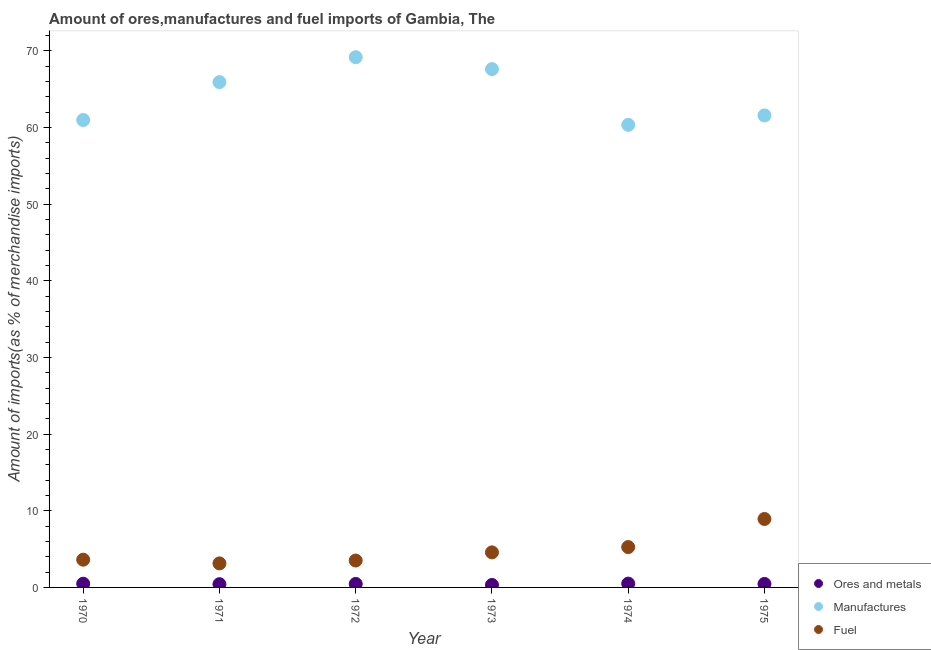How many different coloured dotlines are there?
Ensure brevity in your answer.  3. What is the percentage of fuel imports in 1970?
Your answer should be compact. 3.62. Across all years, what is the maximum percentage of fuel imports?
Ensure brevity in your answer.  8.93. Across all years, what is the minimum percentage of manufactures imports?
Offer a very short reply. 60.34. In which year was the percentage of ores and metals imports maximum?
Make the answer very short. 1974. In which year was the percentage of ores and metals imports minimum?
Offer a very short reply. 1973. What is the total percentage of ores and metals imports in the graph?
Ensure brevity in your answer.  2.64. What is the difference between the percentage of ores and metals imports in 1972 and that in 1973?
Ensure brevity in your answer.  0.14. What is the difference between the percentage of fuel imports in 1975 and the percentage of manufactures imports in 1972?
Provide a succinct answer. -60.23. What is the average percentage of ores and metals imports per year?
Offer a terse response. 0.44. In the year 1974, what is the difference between the percentage of ores and metals imports and percentage of manufactures imports?
Ensure brevity in your answer.  -59.84. What is the ratio of the percentage of ores and metals imports in 1971 to that in 1974?
Offer a terse response. 0.85. Is the percentage of manufactures imports in 1970 less than that in 1975?
Provide a succinct answer. Yes. Is the difference between the percentage of fuel imports in 1972 and 1974 greater than the difference between the percentage of manufactures imports in 1972 and 1974?
Ensure brevity in your answer.  No. What is the difference between the highest and the second highest percentage of manufactures imports?
Your answer should be compact. 1.55. What is the difference between the highest and the lowest percentage of manufactures imports?
Keep it short and to the point. 8.82. Is the sum of the percentage of manufactures imports in 1972 and 1973 greater than the maximum percentage of fuel imports across all years?
Offer a terse response. Yes. Is it the case that in every year, the sum of the percentage of ores and metals imports and percentage of manufactures imports is greater than the percentage of fuel imports?
Provide a succinct answer. Yes. Is the percentage of ores and metals imports strictly less than the percentage of manufactures imports over the years?
Offer a terse response. Yes. What is the difference between two consecutive major ticks on the Y-axis?
Your response must be concise. 10. Are the values on the major ticks of Y-axis written in scientific E-notation?
Provide a succinct answer. No. What is the title of the graph?
Your response must be concise. Amount of ores,manufactures and fuel imports of Gambia, The. Does "Gaseous fuel" appear as one of the legend labels in the graph?
Your answer should be very brief. No. What is the label or title of the X-axis?
Ensure brevity in your answer.  Year. What is the label or title of the Y-axis?
Give a very brief answer. Amount of imports(as % of merchandise imports). What is the Amount of imports(as % of merchandise imports) in Ores and metals in 1970?
Your answer should be compact. 0.49. What is the Amount of imports(as % of merchandise imports) of Manufactures in 1970?
Provide a succinct answer. 60.97. What is the Amount of imports(as % of merchandise imports) of Fuel in 1970?
Offer a terse response. 3.62. What is the Amount of imports(as % of merchandise imports) in Ores and metals in 1971?
Offer a terse response. 0.42. What is the Amount of imports(as % of merchandise imports) in Manufactures in 1971?
Your response must be concise. 65.91. What is the Amount of imports(as % of merchandise imports) in Fuel in 1971?
Make the answer very short. 3.13. What is the Amount of imports(as % of merchandise imports) in Ores and metals in 1972?
Give a very brief answer. 0.46. What is the Amount of imports(as % of merchandise imports) in Manufactures in 1972?
Provide a succinct answer. 69.16. What is the Amount of imports(as % of merchandise imports) of Fuel in 1972?
Provide a short and direct response. 3.51. What is the Amount of imports(as % of merchandise imports) in Ores and metals in 1973?
Provide a succinct answer. 0.32. What is the Amount of imports(as % of merchandise imports) in Manufactures in 1973?
Provide a short and direct response. 67.61. What is the Amount of imports(as % of merchandise imports) of Fuel in 1973?
Offer a terse response. 4.57. What is the Amount of imports(as % of merchandise imports) in Ores and metals in 1974?
Your answer should be very brief. 0.5. What is the Amount of imports(as % of merchandise imports) in Manufactures in 1974?
Give a very brief answer. 60.34. What is the Amount of imports(as % of merchandise imports) in Fuel in 1974?
Offer a very short reply. 5.26. What is the Amount of imports(as % of merchandise imports) in Ores and metals in 1975?
Your answer should be compact. 0.46. What is the Amount of imports(as % of merchandise imports) of Manufactures in 1975?
Your answer should be compact. 61.56. What is the Amount of imports(as % of merchandise imports) of Fuel in 1975?
Give a very brief answer. 8.93. Across all years, what is the maximum Amount of imports(as % of merchandise imports) in Ores and metals?
Offer a very short reply. 0.5. Across all years, what is the maximum Amount of imports(as % of merchandise imports) of Manufactures?
Keep it short and to the point. 69.16. Across all years, what is the maximum Amount of imports(as % of merchandise imports) of Fuel?
Give a very brief answer. 8.93. Across all years, what is the minimum Amount of imports(as % of merchandise imports) of Ores and metals?
Your answer should be very brief. 0.32. Across all years, what is the minimum Amount of imports(as % of merchandise imports) in Manufactures?
Your response must be concise. 60.34. Across all years, what is the minimum Amount of imports(as % of merchandise imports) of Fuel?
Offer a very short reply. 3.13. What is the total Amount of imports(as % of merchandise imports) of Ores and metals in the graph?
Give a very brief answer. 2.64. What is the total Amount of imports(as % of merchandise imports) in Manufactures in the graph?
Provide a short and direct response. 385.54. What is the total Amount of imports(as % of merchandise imports) of Fuel in the graph?
Offer a very short reply. 29.03. What is the difference between the Amount of imports(as % of merchandise imports) in Ores and metals in 1970 and that in 1971?
Provide a succinct answer. 0.06. What is the difference between the Amount of imports(as % of merchandise imports) in Manufactures in 1970 and that in 1971?
Your answer should be compact. -4.94. What is the difference between the Amount of imports(as % of merchandise imports) in Fuel in 1970 and that in 1971?
Provide a succinct answer. 0.48. What is the difference between the Amount of imports(as % of merchandise imports) in Ores and metals in 1970 and that in 1972?
Offer a very short reply. 0.03. What is the difference between the Amount of imports(as % of merchandise imports) of Manufactures in 1970 and that in 1972?
Your answer should be very brief. -8.19. What is the difference between the Amount of imports(as % of merchandise imports) of Fuel in 1970 and that in 1972?
Provide a succinct answer. 0.11. What is the difference between the Amount of imports(as % of merchandise imports) in Ores and metals in 1970 and that in 1973?
Ensure brevity in your answer.  0.17. What is the difference between the Amount of imports(as % of merchandise imports) of Manufactures in 1970 and that in 1973?
Offer a terse response. -6.64. What is the difference between the Amount of imports(as % of merchandise imports) in Fuel in 1970 and that in 1973?
Your answer should be very brief. -0.95. What is the difference between the Amount of imports(as % of merchandise imports) in Ores and metals in 1970 and that in 1974?
Offer a very short reply. -0.01. What is the difference between the Amount of imports(as % of merchandise imports) in Manufactures in 1970 and that in 1974?
Your answer should be very brief. 0.63. What is the difference between the Amount of imports(as % of merchandise imports) in Fuel in 1970 and that in 1974?
Offer a terse response. -1.64. What is the difference between the Amount of imports(as % of merchandise imports) in Ores and metals in 1970 and that in 1975?
Offer a terse response. 0.03. What is the difference between the Amount of imports(as % of merchandise imports) of Manufactures in 1970 and that in 1975?
Your response must be concise. -0.6. What is the difference between the Amount of imports(as % of merchandise imports) of Fuel in 1970 and that in 1975?
Keep it short and to the point. -5.31. What is the difference between the Amount of imports(as % of merchandise imports) of Ores and metals in 1971 and that in 1972?
Your answer should be very brief. -0.03. What is the difference between the Amount of imports(as % of merchandise imports) of Manufactures in 1971 and that in 1972?
Ensure brevity in your answer.  -3.25. What is the difference between the Amount of imports(as % of merchandise imports) in Fuel in 1971 and that in 1972?
Make the answer very short. -0.37. What is the difference between the Amount of imports(as % of merchandise imports) in Ores and metals in 1971 and that in 1973?
Give a very brief answer. 0.1. What is the difference between the Amount of imports(as % of merchandise imports) of Manufactures in 1971 and that in 1973?
Ensure brevity in your answer.  -1.7. What is the difference between the Amount of imports(as % of merchandise imports) of Fuel in 1971 and that in 1973?
Provide a succinct answer. -1.44. What is the difference between the Amount of imports(as % of merchandise imports) in Ores and metals in 1971 and that in 1974?
Your response must be concise. -0.07. What is the difference between the Amount of imports(as % of merchandise imports) of Manufactures in 1971 and that in 1974?
Provide a succinct answer. 5.57. What is the difference between the Amount of imports(as % of merchandise imports) in Fuel in 1971 and that in 1974?
Make the answer very short. -2.13. What is the difference between the Amount of imports(as % of merchandise imports) in Ores and metals in 1971 and that in 1975?
Your answer should be compact. -0.03. What is the difference between the Amount of imports(as % of merchandise imports) in Manufactures in 1971 and that in 1975?
Provide a succinct answer. 4.35. What is the difference between the Amount of imports(as % of merchandise imports) of Fuel in 1971 and that in 1975?
Your answer should be very brief. -5.79. What is the difference between the Amount of imports(as % of merchandise imports) in Ores and metals in 1972 and that in 1973?
Ensure brevity in your answer.  0.14. What is the difference between the Amount of imports(as % of merchandise imports) in Manufactures in 1972 and that in 1973?
Your answer should be very brief. 1.55. What is the difference between the Amount of imports(as % of merchandise imports) of Fuel in 1972 and that in 1973?
Make the answer very short. -1.07. What is the difference between the Amount of imports(as % of merchandise imports) in Ores and metals in 1972 and that in 1974?
Make the answer very short. -0.04. What is the difference between the Amount of imports(as % of merchandise imports) in Manufactures in 1972 and that in 1974?
Offer a very short reply. 8.82. What is the difference between the Amount of imports(as % of merchandise imports) of Fuel in 1972 and that in 1974?
Your answer should be very brief. -1.75. What is the difference between the Amount of imports(as % of merchandise imports) of Ores and metals in 1972 and that in 1975?
Give a very brief answer. 0. What is the difference between the Amount of imports(as % of merchandise imports) of Manufactures in 1972 and that in 1975?
Make the answer very short. 7.59. What is the difference between the Amount of imports(as % of merchandise imports) of Fuel in 1972 and that in 1975?
Offer a terse response. -5.42. What is the difference between the Amount of imports(as % of merchandise imports) in Ores and metals in 1973 and that in 1974?
Your answer should be compact. -0.18. What is the difference between the Amount of imports(as % of merchandise imports) in Manufactures in 1973 and that in 1974?
Provide a short and direct response. 7.27. What is the difference between the Amount of imports(as % of merchandise imports) of Fuel in 1973 and that in 1974?
Provide a short and direct response. -0.69. What is the difference between the Amount of imports(as % of merchandise imports) in Ores and metals in 1973 and that in 1975?
Ensure brevity in your answer.  -0.14. What is the difference between the Amount of imports(as % of merchandise imports) in Manufactures in 1973 and that in 1975?
Your answer should be very brief. 6.04. What is the difference between the Amount of imports(as % of merchandise imports) in Fuel in 1973 and that in 1975?
Make the answer very short. -4.35. What is the difference between the Amount of imports(as % of merchandise imports) in Ores and metals in 1974 and that in 1975?
Provide a succinct answer. 0.04. What is the difference between the Amount of imports(as % of merchandise imports) of Manufactures in 1974 and that in 1975?
Provide a short and direct response. -1.23. What is the difference between the Amount of imports(as % of merchandise imports) of Fuel in 1974 and that in 1975?
Provide a short and direct response. -3.66. What is the difference between the Amount of imports(as % of merchandise imports) of Ores and metals in 1970 and the Amount of imports(as % of merchandise imports) of Manufactures in 1971?
Your answer should be very brief. -65.43. What is the difference between the Amount of imports(as % of merchandise imports) in Ores and metals in 1970 and the Amount of imports(as % of merchandise imports) in Fuel in 1971?
Provide a succinct answer. -2.65. What is the difference between the Amount of imports(as % of merchandise imports) of Manufactures in 1970 and the Amount of imports(as % of merchandise imports) of Fuel in 1971?
Your answer should be very brief. 57.83. What is the difference between the Amount of imports(as % of merchandise imports) in Ores and metals in 1970 and the Amount of imports(as % of merchandise imports) in Manufactures in 1972?
Provide a short and direct response. -68.67. What is the difference between the Amount of imports(as % of merchandise imports) in Ores and metals in 1970 and the Amount of imports(as % of merchandise imports) in Fuel in 1972?
Provide a short and direct response. -3.02. What is the difference between the Amount of imports(as % of merchandise imports) in Manufactures in 1970 and the Amount of imports(as % of merchandise imports) in Fuel in 1972?
Provide a short and direct response. 57.46. What is the difference between the Amount of imports(as % of merchandise imports) in Ores and metals in 1970 and the Amount of imports(as % of merchandise imports) in Manufactures in 1973?
Offer a terse response. -67.12. What is the difference between the Amount of imports(as % of merchandise imports) in Ores and metals in 1970 and the Amount of imports(as % of merchandise imports) in Fuel in 1973?
Make the answer very short. -4.09. What is the difference between the Amount of imports(as % of merchandise imports) in Manufactures in 1970 and the Amount of imports(as % of merchandise imports) in Fuel in 1973?
Offer a terse response. 56.39. What is the difference between the Amount of imports(as % of merchandise imports) of Ores and metals in 1970 and the Amount of imports(as % of merchandise imports) of Manufactures in 1974?
Your response must be concise. -59.85. What is the difference between the Amount of imports(as % of merchandise imports) in Ores and metals in 1970 and the Amount of imports(as % of merchandise imports) in Fuel in 1974?
Provide a succinct answer. -4.78. What is the difference between the Amount of imports(as % of merchandise imports) of Manufactures in 1970 and the Amount of imports(as % of merchandise imports) of Fuel in 1974?
Offer a very short reply. 55.7. What is the difference between the Amount of imports(as % of merchandise imports) of Ores and metals in 1970 and the Amount of imports(as % of merchandise imports) of Manufactures in 1975?
Offer a very short reply. -61.08. What is the difference between the Amount of imports(as % of merchandise imports) in Ores and metals in 1970 and the Amount of imports(as % of merchandise imports) in Fuel in 1975?
Ensure brevity in your answer.  -8.44. What is the difference between the Amount of imports(as % of merchandise imports) in Manufactures in 1970 and the Amount of imports(as % of merchandise imports) in Fuel in 1975?
Keep it short and to the point. 52.04. What is the difference between the Amount of imports(as % of merchandise imports) of Ores and metals in 1971 and the Amount of imports(as % of merchandise imports) of Manufactures in 1972?
Your answer should be very brief. -68.74. What is the difference between the Amount of imports(as % of merchandise imports) in Ores and metals in 1971 and the Amount of imports(as % of merchandise imports) in Fuel in 1972?
Provide a short and direct response. -3.09. What is the difference between the Amount of imports(as % of merchandise imports) of Manufactures in 1971 and the Amount of imports(as % of merchandise imports) of Fuel in 1972?
Make the answer very short. 62.4. What is the difference between the Amount of imports(as % of merchandise imports) of Ores and metals in 1971 and the Amount of imports(as % of merchandise imports) of Manufactures in 1973?
Your response must be concise. -67.18. What is the difference between the Amount of imports(as % of merchandise imports) in Ores and metals in 1971 and the Amount of imports(as % of merchandise imports) in Fuel in 1973?
Keep it short and to the point. -4.15. What is the difference between the Amount of imports(as % of merchandise imports) of Manufactures in 1971 and the Amount of imports(as % of merchandise imports) of Fuel in 1973?
Keep it short and to the point. 61.34. What is the difference between the Amount of imports(as % of merchandise imports) in Ores and metals in 1971 and the Amount of imports(as % of merchandise imports) in Manufactures in 1974?
Give a very brief answer. -59.92. What is the difference between the Amount of imports(as % of merchandise imports) of Ores and metals in 1971 and the Amount of imports(as % of merchandise imports) of Fuel in 1974?
Provide a succinct answer. -4.84. What is the difference between the Amount of imports(as % of merchandise imports) of Manufactures in 1971 and the Amount of imports(as % of merchandise imports) of Fuel in 1974?
Offer a terse response. 60.65. What is the difference between the Amount of imports(as % of merchandise imports) in Ores and metals in 1971 and the Amount of imports(as % of merchandise imports) in Manufactures in 1975?
Offer a terse response. -61.14. What is the difference between the Amount of imports(as % of merchandise imports) in Ores and metals in 1971 and the Amount of imports(as % of merchandise imports) in Fuel in 1975?
Offer a terse response. -8.51. What is the difference between the Amount of imports(as % of merchandise imports) of Manufactures in 1971 and the Amount of imports(as % of merchandise imports) of Fuel in 1975?
Make the answer very short. 56.98. What is the difference between the Amount of imports(as % of merchandise imports) in Ores and metals in 1972 and the Amount of imports(as % of merchandise imports) in Manufactures in 1973?
Your answer should be compact. -67.15. What is the difference between the Amount of imports(as % of merchandise imports) of Ores and metals in 1972 and the Amount of imports(as % of merchandise imports) of Fuel in 1973?
Your answer should be compact. -4.12. What is the difference between the Amount of imports(as % of merchandise imports) in Manufactures in 1972 and the Amount of imports(as % of merchandise imports) in Fuel in 1973?
Your answer should be compact. 64.58. What is the difference between the Amount of imports(as % of merchandise imports) in Ores and metals in 1972 and the Amount of imports(as % of merchandise imports) in Manufactures in 1974?
Offer a very short reply. -59.88. What is the difference between the Amount of imports(as % of merchandise imports) of Ores and metals in 1972 and the Amount of imports(as % of merchandise imports) of Fuel in 1974?
Provide a short and direct response. -4.81. What is the difference between the Amount of imports(as % of merchandise imports) of Manufactures in 1972 and the Amount of imports(as % of merchandise imports) of Fuel in 1974?
Provide a short and direct response. 63.89. What is the difference between the Amount of imports(as % of merchandise imports) of Ores and metals in 1972 and the Amount of imports(as % of merchandise imports) of Manufactures in 1975?
Offer a terse response. -61.11. What is the difference between the Amount of imports(as % of merchandise imports) of Ores and metals in 1972 and the Amount of imports(as % of merchandise imports) of Fuel in 1975?
Give a very brief answer. -8.47. What is the difference between the Amount of imports(as % of merchandise imports) in Manufactures in 1972 and the Amount of imports(as % of merchandise imports) in Fuel in 1975?
Your answer should be very brief. 60.23. What is the difference between the Amount of imports(as % of merchandise imports) in Ores and metals in 1973 and the Amount of imports(as % of merchandise imports) in Manufactures in 1974?
Offer a very short reply. -60.02. What is the difference between the Amount of imports(as % of merchandise imports) of Ores and metals in 1973 and the Amount of imports(as % of merchandise imports) of Fuel in 1974?
Provide a short and direct response. -4.94. What is the difference between the Amount of imports(as % of merchandise imports) of Manufactures in 1973 and the Amount of imports(as % of merchandise imports) of Fuel in 1974?
Offer a terse response. 62.34. What is the difference between the Amount of imports(as % of merchandise imports) in Ores and metals in 1973 and the Amount of imports(as % of merchandise imports) in Manufactures in 1975?
Provide a succinct answer. -61.24. What is the difference between the Amount of imports(as % of merchandise imports) of Ores and metals in 1973 and the Amount of imports(as % of merchandise imports) of Fuel in 1975?
Offer a very short reply. -8.61. What is the difference between the Amount of imports(as % of merchandise imports) of Manufactures in 1973 and the Amount of imports(as % of merchandise imports) of Fuel in 1975?
Your answer should be compact. 58.68. What is the difference between the Amount of imports(as % of merchandise imports) in Ores and metals in 1974 and the Amount of imports(as % of merchandise imports) in Manufactures in 1975?
Make the answer very short. -61.07. What is the difference between the Amount of imports(as % of merchandise imports) in Ores and metals in 1974 and the Amount of imports(as % of merchandise imports) in Fuel in 1975?
Keep it short and to the point. -8.43. What is the difference between the Amount of imports(as % of merchandise imports) of Manufactures in 1974 and the Amount of imports(as % of merchandise imports) of Fuel in 1975?
Make the answer very short. 51.41. What is the average Amount of imports(as % of merchandise imports) in Ores and metals per year?
Offer a terse response. 0.44. What is the average Amount of imports(as % of merchandise imports) of Manufactures per year?
Offer a very short reply. 64.26. What is the average Amount of imports(as % of merchandise imports) in Fuel per year?
Provide a short and direct response. 4.84. In the year 1970, what is the difference between the Amount of imports(as % of merchandise imports) of Ores and metals and Amount of imports(as % of merchandise imports) of Manufactures?
Your answer should be very brief. -60.48. In the year 1970, what is the difference between the Amount of imports(as % of merchandise imports) in Ores and metals and Amount of imports(as % of merchandise imports) in Fuel?
Give a very brief answer. -3.13. In the year 1970, what is the difference between the Amount of imports(as % of merchandise imports) in Manufactures and Amount of imports(as % of merchandise imports) in Fuel?
Provide a succinct answer. 57.35. In the year 1971, what is the difference between the Amount of imports(as % of merchandise imports) of Ores and metals and Amount of imports(as % of merchandise imports) of Manufactures?
Keep it short and to the point. -65.49. In the year 1971, what is the difference between the Amount of imports(as % of merchandise imports) in Ores and metals and Amount of imports(as % of merchandise imports) in Fuel?
Your response must be concise. -2.71. In the year 1971, what is the difference between the Amount of imports(as % of merchandise imports) of Manufactures and Amount of imports(as % of merchandise imports) of Fuel?
Give a very brief answer. 62.78. In the year 1972, what is the difference between the Amount of imports(as % of merchandise imports) of Ores and metals and Amount of imports(as % of merchandise imports) of Manufactures?
Your answer should be compact. -68.7. In the year 1972, what is the difference between the Amount of imports(as % of merchandise imports) in Ores and metals and Amount of imports(as % of merchandise imports) in Fuel?
Offer a very short reply. -3.05. In the year 1972, what is the difference between the Amount of imports(as % of merchandise imports) of Manufactures and Amount of imports(as % of merchandise imports) of Fuel?
Your response must be concise. 65.65. In the year 1973, what is the difference between the Amount of imports(as % of merchandise imports) in Ores and metals and Amount of imports(as % of merchandise imports) in Manufactures?
Keep it short and to the point. -67.29. In the year 1973, what is the difference between the Amount of imports(as % of merchandise imports) of Ores and metals and Amount of imports(as % of merchandise imports) of Fuel?
Offer a very short reply. -4.25. In the year 1973, what is the difference between the Amount of imports(as % of merchandise imports) in Manufactures and Amount of imports(as % of merchandise imports) in Fuel?
Your answer should be very brief. 63.03. In the year 1974, what is the difference between the Amount of imports(as % of merchandise imports) in Ores and metals and Amount of imports(as % of merchandise imports) in Manufactures?
Provide a succinct answer. -59.84. In the year 1974, what is the difference between the Amount of imports(as % of merchandise imports) of Ores and metals and Amount of imports(as % of merchandise imports) of Fuel?
Make the answer very short. -4.77. In the year 1974, what is the difference between the Amount of imports(as % of merchandise imports) of Manufactures and Amount of imports(as % of merchandise imports) of Fuel?
Offer a very short reply. 55.07. In the year 1975, what is the difference between the Amount of imports(as % of merchandise imports) of Ores and metals and Amount of imports(as % of merchandise imports) of Manufactures?
Your answer should be very brief. -61.11. In the year 1975, what is the difference between the Amount of imports(as % of merchandise imports) in Ores and metals and Amount of imports(as % of merchandise imports) in Fuel?
Your answer should be compact. -8.47. In the year 1975, what is the difference between the Amount of imports(as % of merchandise imports) in Manufactures and Amount of imports(as % of merchandise imports) in Fuel?
Provide a short and direct response. 52.64. What is the ratio of the Amount of imports(as % of merchandise imports) of Ores and metals in 1970 to that in 1971?
Keep it short and to the point. 1.15. What is the ratio of the Amount of imports(as % of merchandise imports) of Manufactures in 1970 to that in 1971?
Offer a very short reply. 0.93. What is the ratio of the Amount of imports(as % of merchandise imports) in Fuel in 1970 to that in 1971?
Give a very brief answer. 1.15. What is the ratio of the Amount of imports(as % of merchandise imports) of Ores and metals in 1970 to that in 1972?
Your answer should be very brief. 1.06. What is the ratio of the Amount of imports(as % of merchandise imports) of Manufactures in 1970 to that in 1972?
Give a very brief answer. 0.88. What is the ratio of the Amount of imports(as % of merchandise imports) of Fuel in 1970 to that in 1972?
Give a very brief answer. 1.03. What is the ratio of the Amount of imports(as % of merchandise imports) of Ores and metals in 1970 to that in 1973?
Ensure brevity in your answer.  1.52. What is the ratio of the Amount of imports(as % of merchandise imports) in Manufactures in 1970 to that in 1973?
Your answer should be very brief. 0.9. What is the ratio of the Amount of imports(as % of merchandise imports) of Fuel in 1970 to that in 1973?
Provide a short and direct response. 0.79. What is the ratio of the Amount of imports(as % of merchandise imports) in Ores and metals in 1970 to that in 1974?
Offer a terse response. 0.98. What is the ratio of the Amount of imports(as % of merchandise imports) in Manufactures in 1970 to that in 1974?
Make the answer very short. 1.01. What is the ratio of the Amount of imports(as % of merchandise imports) in Fuel in 1970 to that in 1974?
Give a very brief answer. 0.69. What is the ratio of the Amount of imports(as % of merchandise imports) of Ores and metals in 1970 to that in 1975?
Your answer should be very brief. 1.07. What is the ratio of the Amount of imports(as % of merchandise imports) of Manufactures in 1970 to that in 1975?
Your response must be concise. 0.99. What is the ratio of the Amount of imports(as % of merchandise imports) of Fuel in 1970 to that in 1975?
Provide a short and direct response. 0.41. What is the ratio of the Amount of imports(as % of merchandise imports) in Ores and metals in 1971 to that in 1972?
Offer a terse response. 0.92. What is the ratio of the Amount of imports(as % of merchandise imports) of Manufactures in 1971 to that in 1972?
Ensure brevity in your answer.  0.95. What is the ratio of the Amount of imports(as % of merchandise imports) in Fuel in 1971 to that in 1972?
Provide a succinct answer. 0.89. What is the ratio of the Amount of imports(as % of merchandise imports) in Ores and metals in 1971 to that in 1973?
Make the answer very short. 1.32. What is the ratio of the Amount of imports(as % of merchandise imports) of Manufactures in 1971 to that in 1973?
Ensure brevity in your answer.  0.97. What is the ratio of the Amount of imports(as % of merchandise imports) in Fuel in 1971 to that in 1973?
Your response must be concise. 0.69. What is the ratio of the Amount of imports(as % of merchandise imports) of Ores and metals in 1971 to that in 1974?
Provide a short and direct response. 0.85. What is the ratio of the Amount of imports(as % of merchandise imports) in Manufactures in 1971 to that in 1974?
Ensure brevity in your answer.  1.09. What is the ratio of the Amount of imports(as % of merchandise imports) in Fuel in 1971 to that in 1974?
Offer a terse response. 0.6. What is the ratio of the Amount of imports(as % of merchandise imports) of Ores and metals in 1971 to that in 1975?
Give a very brief answer. 0.93. What is the ratio of the Amount of imports(as % of merchandise imports) in Manufactures in 1971 to that in 1975?
Your answer should be compact. 1.07. What is the ratio of the Amount of imports(as % of merchandise imports) of Fuel in 1971 to that in 1975?
Keep it short and to the point. 0.35. What is the ratio of the Amount of imports(as % of merchandise imports) of Ores and metals in 1972 to that in 1973?
Offer a very short reply. 1.43. What is the ratio of the Amount of imports(as % of merchandise imports) in Manufactures in 1972 to that in 1973?
Give a very brief answer. 1.02. What is the ratio of the Amount of imports(as % of merchandise imports) of Fuel in 1972 to that in 1973?
Your answer should be compact. 0.77. What is the ratio of the Amount of imports(as % of merchandise imports) in Ores and metals in 1972 to that in 1974?
Make the answer very short. 0.92. What is the ratio of the Amount of imports(as % of merchandise imports) of Manufactures in 1972 to that in 1974?
Your response must be concise. 1.15. What is the ratio of the Amount of imports(as % of merchandise imports) in Fuel in 1972 to that in 1974?
Your answer should be very brief. 0.67. What is the ratio of the Amount of imports(as % of merchandise imports) in Manufactures in 1972 to that in 1975?
Keep it short and to the point. 1.12. What is the ratio of the Amount of imports(as % of merchandise imports) of Fuel in 1972 to that in 1975?
Provide a succinct answer. 0.39. What is the ratio of the Amount of imports(as % of merchandise imports) of Ores and metals in 1973 to that in 1974?
Your response must be concise. 0.65. What is the ratio of the Amount of imports(as % of merchandise imports) of Manufactures in 1973 to that in 1974?
Provide a short and direct response. 1.12. What is the ratio of the Amount of imports(as % of merchandise imports) of Fuel in 1973 to that in 1974?
Keep it short and to the point. 0.87. What is the ratio of the Amount of imports(as % of merchandise imports) of Ores and metals in 1973 to that in 1975?
Offer a very short reply. 0.7. What is the ratio of the Amount of imports(as % of merchandise imports) in Manufactures in 1973 to that in 1975?
Ensure brevity in your answer.  1.1. What is the ratio of the Amount of imports(as % of merchandise imports) in Fuel in 1973 to that in 1975?
Offer a terse response. 0.51. What is the ratio of the Amount of imports(as % of merchandise imports) in Ores and metals in 1974 to that in 1975?
Offer a terse response. 1.09. What is the ratio of the Amount of imports(as % of merchandise imports) of Manufactures in 1974 to that in 1975?
Ensure brevity in your answer.  0.98. What is the ratio of the Amount of imports(as % of merchandise imports) of Fuel in 1974 to that in 1975?
Provide a succinct answer. 0.59. What is the difference between the highest and the second highest Amount of imports(as % of merchandise imports) in Ores and metals?
Offer a terse response. 0.01. What is the difference between the highest and the second highest Amount of imports(as % of merchandise imports) in Manufactures?
Give a very brief answer. 1.55. What is the difference between the highest and the second highest Amount of imports(as % of merchandise imports) of Fuel?
Make the answer very short. 3.66. What is the difference between the highest and the lowest Amount of imports(as % of merchandise imports) of Ores and metals?
Provide a short and direct response. 0.18. What is the difference between the highest and the lowest Amount of imports(as % of merchandise imports) in Manufactures?
Keep it short and to the point. 8.82. What is the difference between the highest and the lowest Amount of imports(as % of merchandise imports) of Fuel?
Provide a short and direct response. 5.79. 